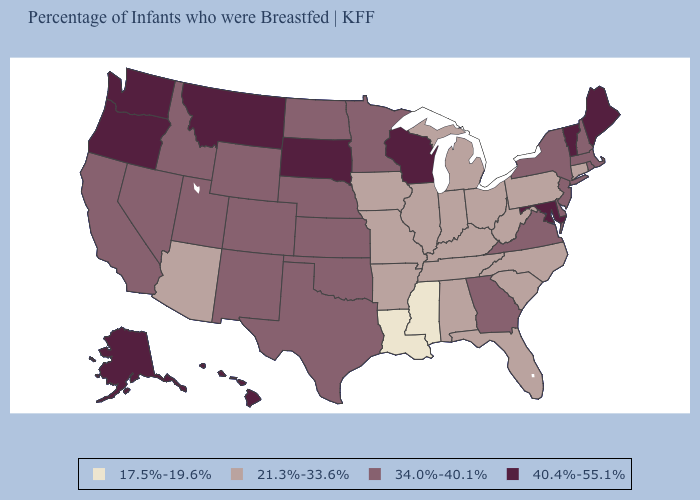What is the value of Michigan?
Be succinct. 21.3%-33.6%. What is the highest value in states that border Nevada?
Short answer required. 40.4%-55.1%. What is the value of Hawaii?
Quick response, please. 40.4%-55.1%. What is the value of Washington?
Keep it brief. 40.4%-55.1%. Name the states that have a value in the range 34.0%-40.1%?
Answer briefly. California, Colorado, Delaware, Georgia, Idaho, Kansas, Massachusetts, Minnesota, Nebraska, Nevada, New Hampshire, New Jersey, New Mexico, New York, North Dakota, Oklahoma, Rhode Island, Texas, Utah, Virginia, Wyoming. Does California have the highest value in the West?
Quick response, please. No. What is the highest value in states that border North Dakota?
Write a very short answer. 40.4%-55.1%. What is the value of Nebraska?
Concise answer only. 34.0%-40.1%. Is the legend a continuous bar?
Short answer required. No. What is the value of Louisiana?
Quick response, please. 17.5%-19.6%. Among the states that border Louisiana , does Mississippi have the highest value?
Be succinct. No. Does Nebraska have the lowest value in the USA?
Write a very short answer. No. What is the value of Maryland?
Answer briefly. 40.4%-55.1%. Among the states that border Colorado , does Arizona have the highest value?
Keep it brief. No. Does Louisiana have a higher value than California?
Quick response, please. No. 